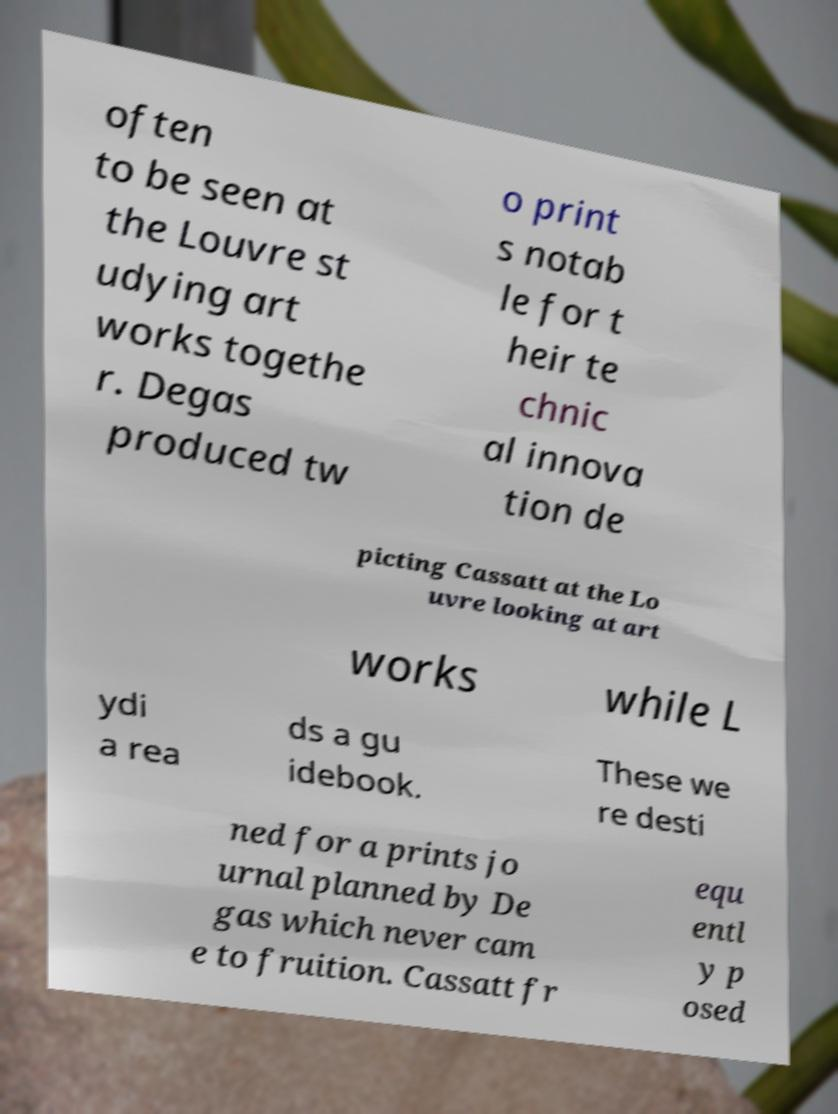I need the written content from this picture converted into text. Can you do that? often to be seen at the Louvre st udying art works togethe r. Degas produced tw o print s notab le for t heir te chnic al innova tion de picting Cassatt at the Lo uvre looking at art works while L ydi a rea ds a gu idebook. These we re desti ned for a prints jo urnal planned by De gas which never cam e to fruition. Cassatt fr equ entl y p osed 